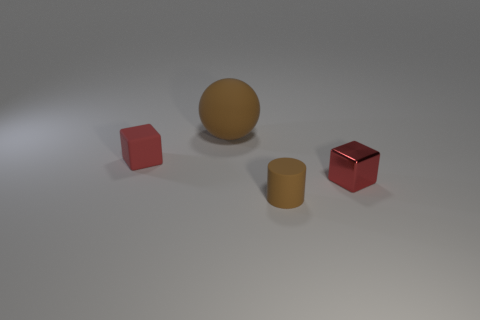What materials are the objects made of in this scene? The two square-shaped objects appear to be made of metal and rubber respectively, while the spherical and cylindrical objects seem to be made from the same materials as their square counterparts. 